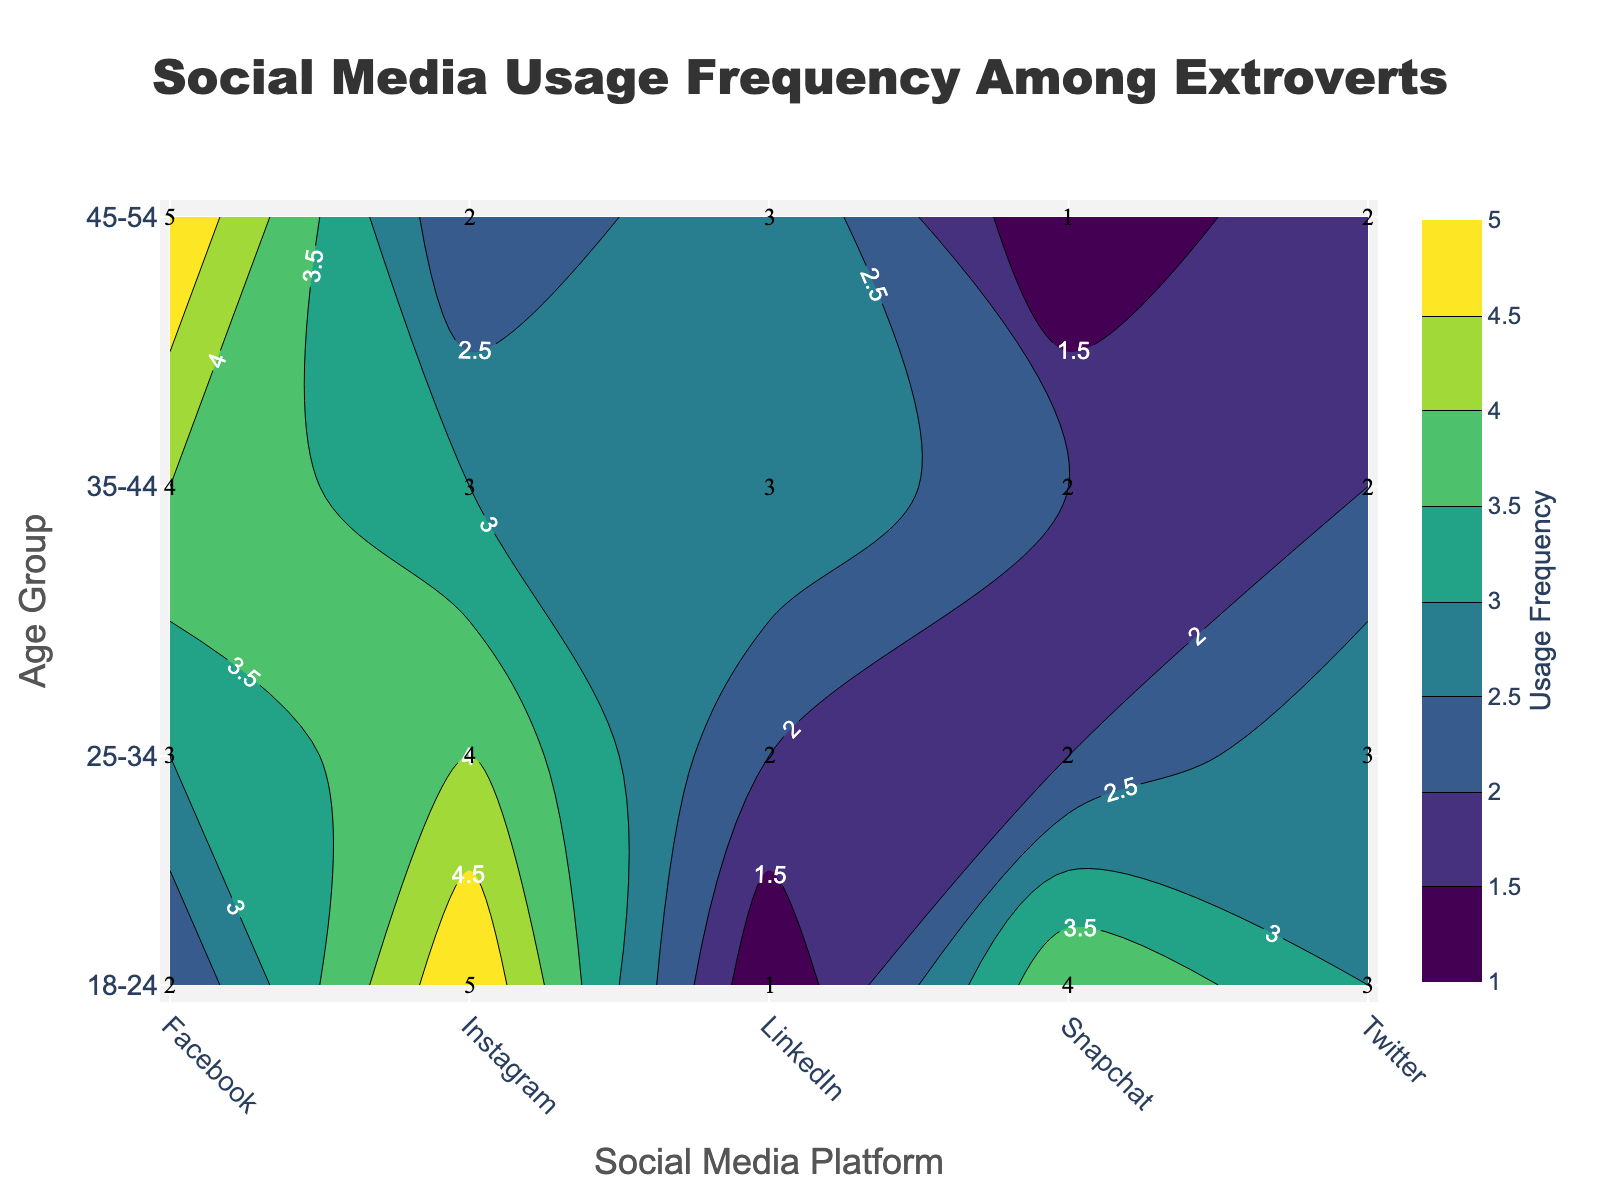What is the title of the contour plot? The contour plot's title is located at the top center and is displayed in a large, bold font. It reads "Social Media Usage Frequency Among Extroverts".
Answer: Social Media Usage Frequency Among Extroverts Which age group has the highest usage frequency for Facebook? To find the highest usage frequency for Facebook, look at the contour lines and labels corresponding to Facebook. The 45-54 age group shows the highest value in this category.
Answer: 45-54 Which social media platform shows the lowest usage frequency among the 18-24 age group? Scan the 18-24 age group row for the lowest value; it is LinkedIn with a frequency of 1.
Answer: LinkedIn What is the average usage frequency for Instagram across all age groups? Sum the usage frequencies for Instagram (5 + 4 + 3 + 2) = 14, then divide by the number of age groups (4). The calculation is 14 / 4 = 3.5.
Answer: 3.5 Compare Twitter usage between the 18-24 and 35-44 age groups. Which group uses it more frequently? Look at the values for Twitter in the 18-24 and 35-44 age groups. The 18-24 age group uses Twitter with a frequency of 3, while the 35-44 age group has a frequency of 2; thus, the 18-24 group uses it more frequently.
Answer: 18-24 Which platform shows the most significant increase in usage frequency as the age group goes from 18-24 to 45-54? Compare the values across the age groups for each platform. Facebook shows an increase from 2 (18-24) to 5 (45-54), which is the most significant increase.
Answer: Facebook What is the total usage frequency of Snapchat among all age groups? Add the usage frequencies of Snapchat for all age groups: 4 (18-24) + 2 (25-34) + 2 (35-44) + 1 (45-54). Thus, 4 + 2 + 2 + 1 = 9.
Answer: 9 Which platform has the least variation in usage frequency across different age groups? Calculate the range (max-min) for each platform: Facebook (5-2=3), Instagram (5-2=3), Twitter (3-2=1), Snapchat (4-1=3), LinkedIn (3-1=2). Twitter has the least variation with a range of 1.
Answer: Twitter How many platforms have a usage frequency of 3 or more in the 35-44 age group? Check the 35-44 age group row for values equal to or greater than 3. The platforms are Facebook (4), Instagram (3), LinkedIn (3). Thus, there are 3 platforms.
Answer: 3 What is the usage frequency of LinkedIn for the 25-34 age group, and how does it compare to the 45-54 age group? Find the values for LinkedIn in the 25-34 age group (2) and 45-54 age group (3). The 45-54 age group has a higher usage frequency.
Answer: 2 for 25-34, 3 for 45-54 